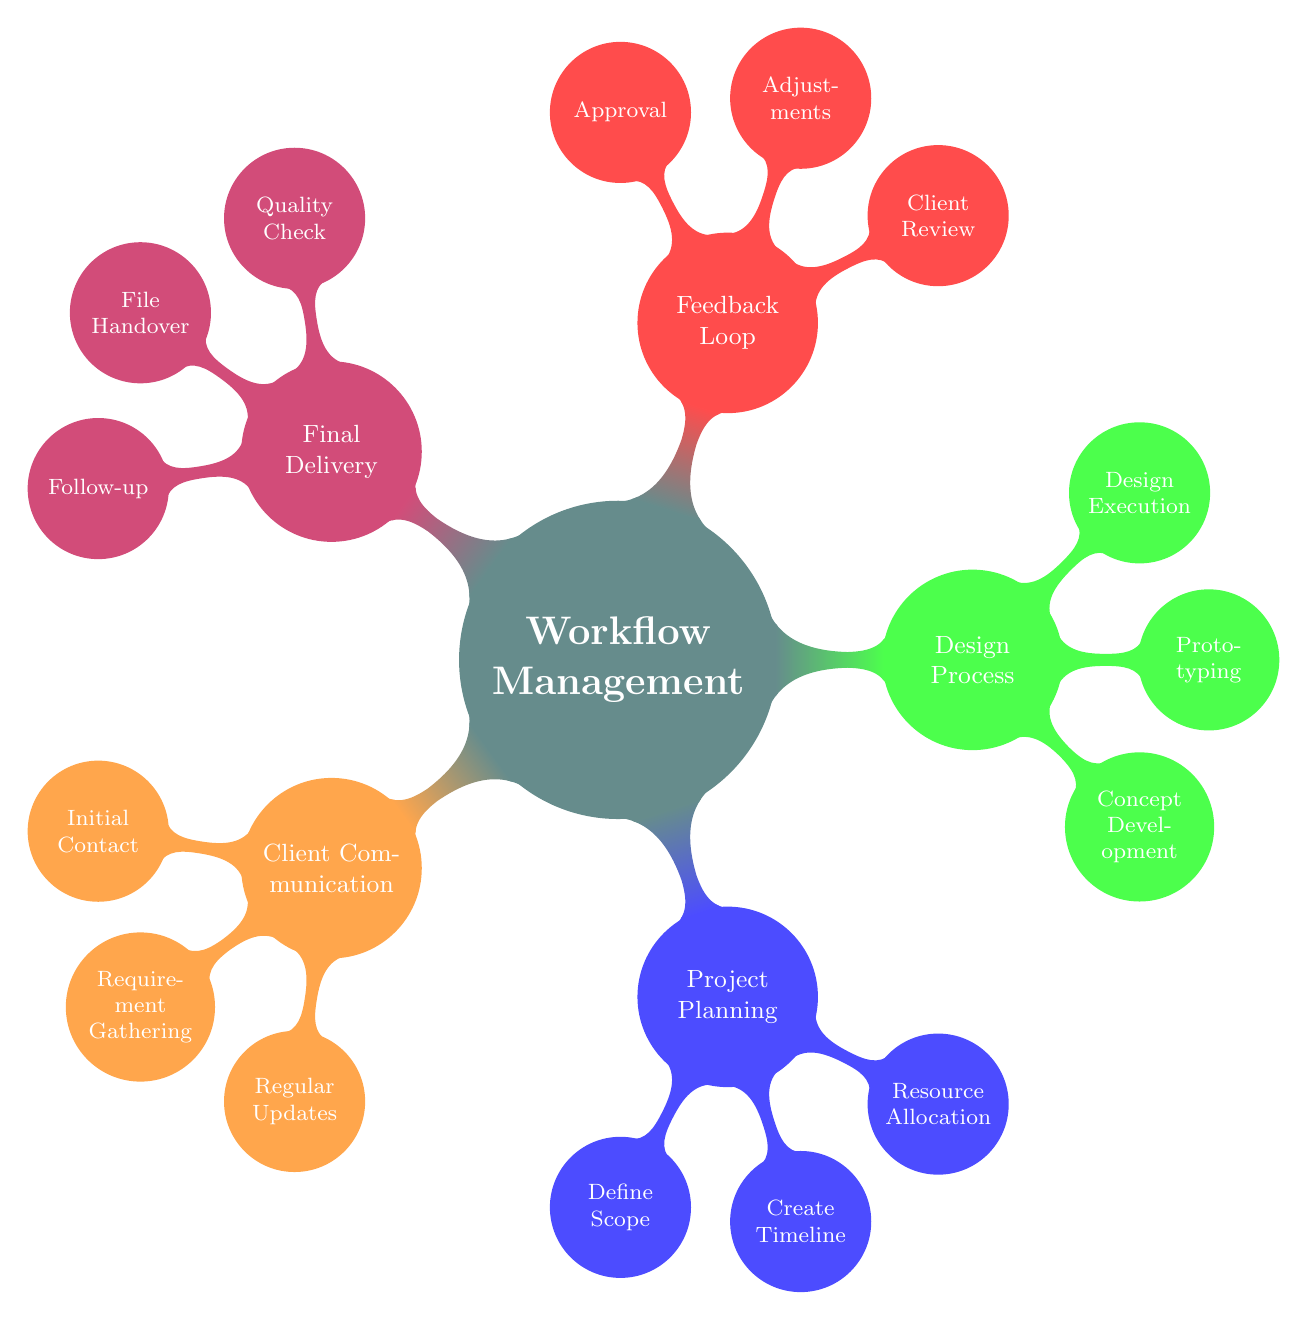What is the main node of the diagram? The main node is explicitly labeled at the center of the diagram. It represents the primary concept and has a distinct color and size. The answer is found directly in the diagram's title.
Answer: Workflow Management How many branches are there? Each branch originates from the main node and represents a specific aspect of the workflow. By counting the branches emanating from the main node, one can determine the number of distinct areas covered in this workflow management.
Answer: 5 Which branch contains the sub-node "Prototyping"? The sub-node labeled "Prototyping" is found under one of the branches. To identify which branch it belongs to, it is necessary to look for the relevant labels associated with the design and development stages in the diagram.
Answer: Design Process What are the three sub-nodes under "Final Delivery"? By examining the "Final Delivery" branch, you can list all associated sub-nodes, as they are clearly marked under their corresponding branch label in the diagram.
Answer: Quality Check, File Handover, Follow-up Which branch has a sub-node related to "Client Review"? This sub-node is located under a specific branch dedicated to capturing responses and revisions from the client. To find the answer, one must look at the feedback mechanism segments in the diagram.
Answer: Feedback Loop How many sub-nodes are there under "Project Planning"? By checking under the "Project Planning" branch, the number of sub-nodes can be counted directly from the diagram. Each sub-node is connected to the main branch within the diagram structure.
Answer: 3 Which branch contributes to the "Design Execution"? The sub-node for "Design Execution" is directly related to one of the workflow areas focused on producing the final visual assets. Identifying the corresponding branch helps in pinpointing its location.
Answer: Design Process What is the last step before final delivery? To identify the final step in the process right before the delivery of the archive, one can trace the feedback and approval stages which lead into this final workflow phase.
Answer: Approval How many sub-nodes does "Client Communication" have? The number of sub-nodes can be easily determined by counting each individual item listed under the "Client Communication" branch.
Answer: 3 